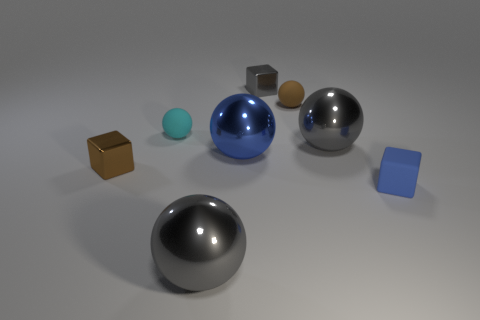What is the size of the gray object in front of the large blue object?
Provide a succinct answer. Large. How many metallic objects are to the left of the big blue shiny ball that is in front of the tiny metal cube on the right side of the tiny cyan thing?
Give a very brief answer. 2. The tiny block to the left of the big gray shiny object in front of the tiny matte block is what color?
Ensure brevity in your answer.  Brown. Are there any purple shiny cylinders of the same size as the brown cube?
Your response must be concise. No. There is a small brown thing on the left side of the metal object behind the gray ball that is right of the brown sphere; what is its material?
Your answer should be compact. Metal. There is a small cube that is left of the cyan rubber ball; what number of shiny spheres are behind it?
Offer a very short reply. 2. Is the size of the thing on the left side of the cyan object the same as the blue metallic sphere?
Your answer should be compact. No. What number of big blue objects have the same shape as the brown rubber thing?
Offer a very short reply. 1. What shape is the tiny blue object?
Offer a very short reply. Cube. Are there an equal number of tiny blue things on the left side of the brown metal block and tiny blue blocks?
Make the answer very short. No. 